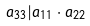<formula> <loc_0><loc_0><loc_500><loc_500>a _ { 3 3 } | a _ { 1 1 } \cdot a _ { 2 2 }</formula> 